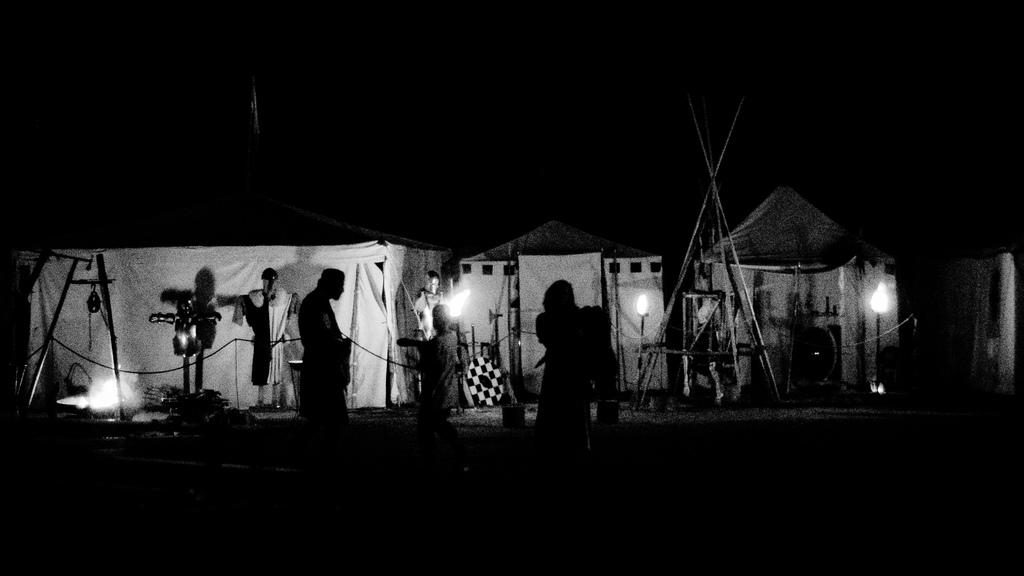What time of day is depicted in the image? The image depicts a night view. What structures are visible in the image? There are tents with lights in the image. What can be seen in the image besides the tents? There are people standing in the dark in the image. What is the lighting situation in the area behind the tents? The area behind the tents is dark. How does the goose shake its feathers in the image? There is no goose present in the image, so it cannot be determined how a goose might shake its feathers. 